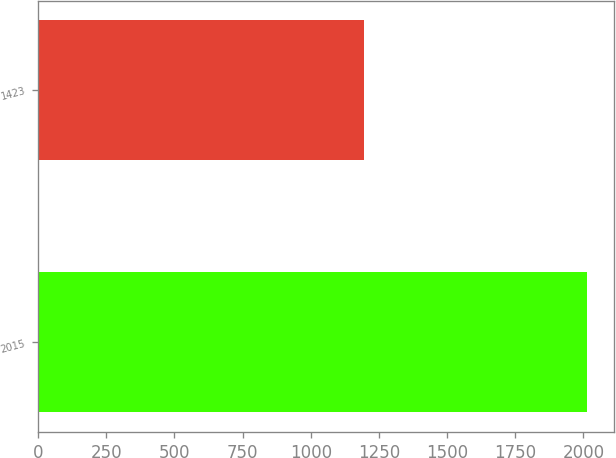Convert chart to OTSL. <chart><loc_0><loc_0><loc_500><loc_500><bar_chart><fcel>2015<fcel>1423<nl><fcel>2013<fcel>1195<nl></chart> 